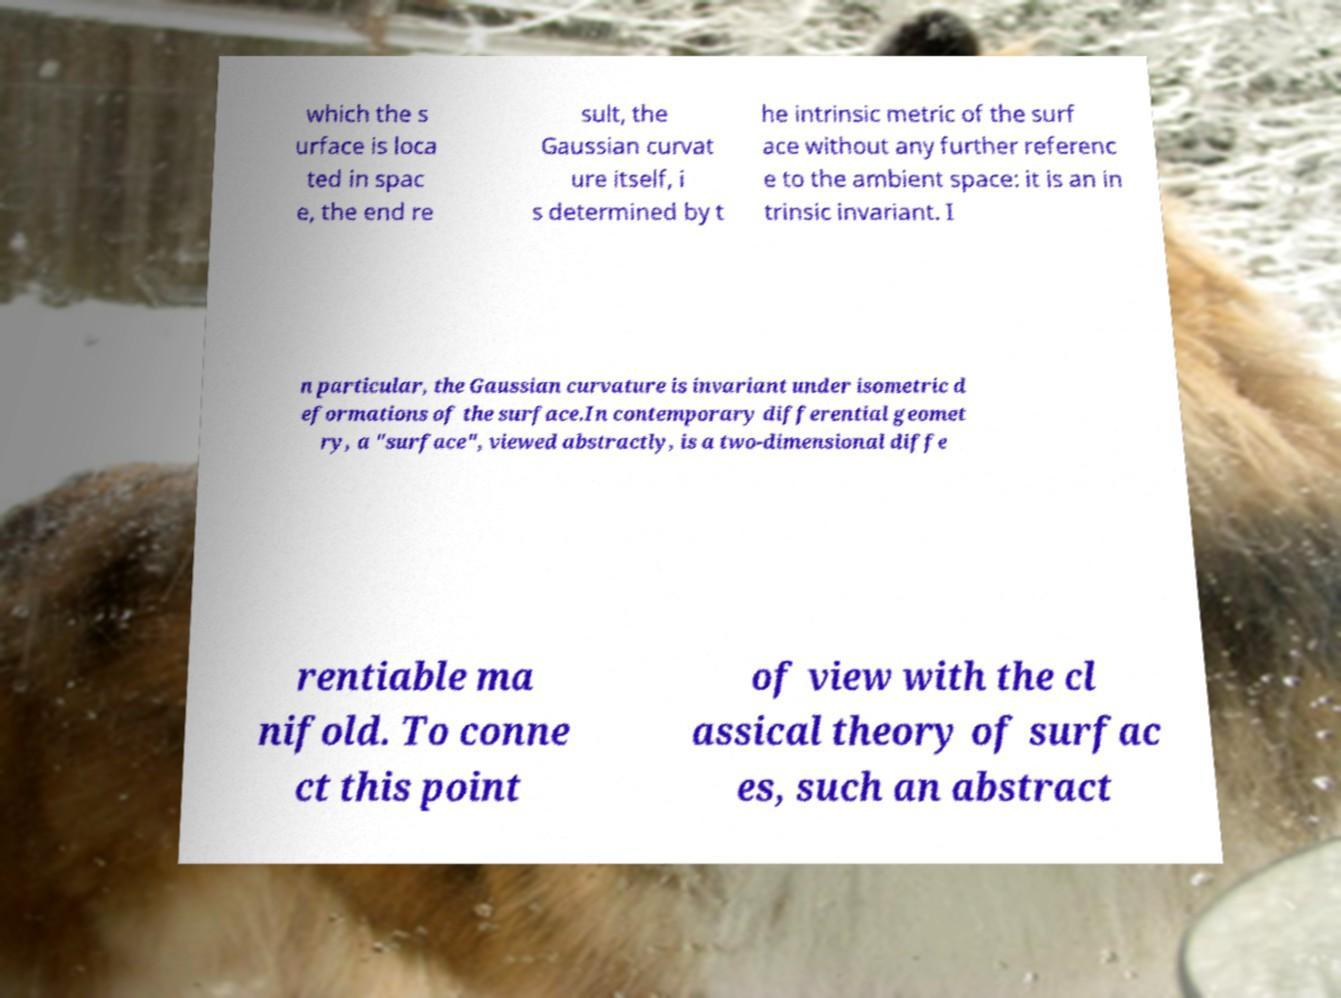For documentation purposes, I need the text within this image transcribed. Could you provide that? which the s urface is loca ted in spac e, the end re sult, the Gaussian curvat ure itself, i s determined by t he intrinsic metric of the surf ace without any further referenc e to the ambient space: it is an in trinsic invariant. I n particular, the Gaussian curvature is invariant under isometric d eformations of the surface.In contemporary differential geomet ry, a "surface", viewed abstractly, is a two-dimensional diffe rentiable ma nifold. To conne ct this point of view with the cl assical theory of surfac es, such an abstract 